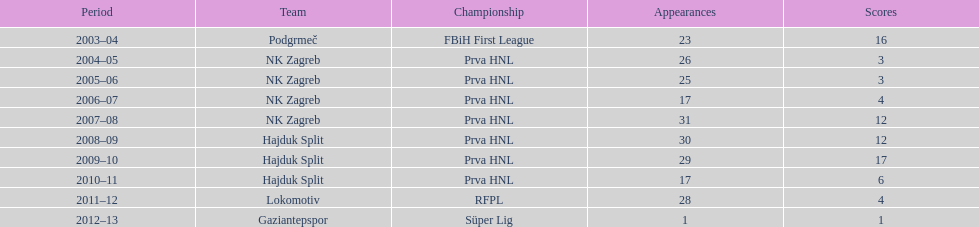Can you parse all the data within this table? {'header': ['Period', 'Team', 'Championship', 'Appearances', 'Scores'], 'rows': [['2003–04', 'Podgrmeč', 'FBiH First League', '23', '16'], ['2004–05', 'NK Zagreb', 'Prva HNL', '26', '3'], ['2005–06', 'NK Zagreb', 'Prva HNL', '25', '3'], ['2006–07', 'NK Zagreb', 'Prva HNL', '17', '4'], ['2007–08', 'NK Zagreb', 'Prva HNL', '31', '12'], ['2008–09', 'Hajduk Split', 'Prva HNL', '30', '12'], ['2009–10', 'Hajduk Split', 'Prva HNL', '29', '17'], ['2010–11', 'Hajduk Split', 'Prva HNL', '17', '6'], ['2011–12', 'Lokomotiv', 'RFPL', '28', '4'], ['2012–13', 'Gaziantepspor', 'Süper Lig', '1', '1']]} The team with the most goals Hajduk Split. 